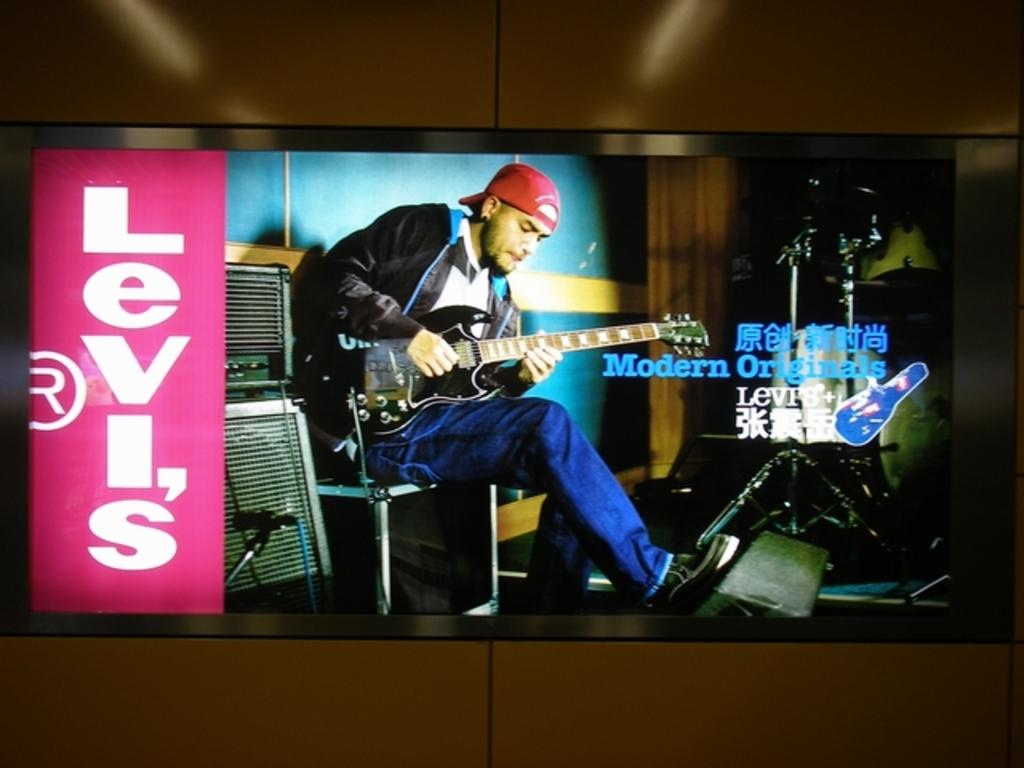<image>
Summarize the visual content of the image. a sign that has the word Levis on it 